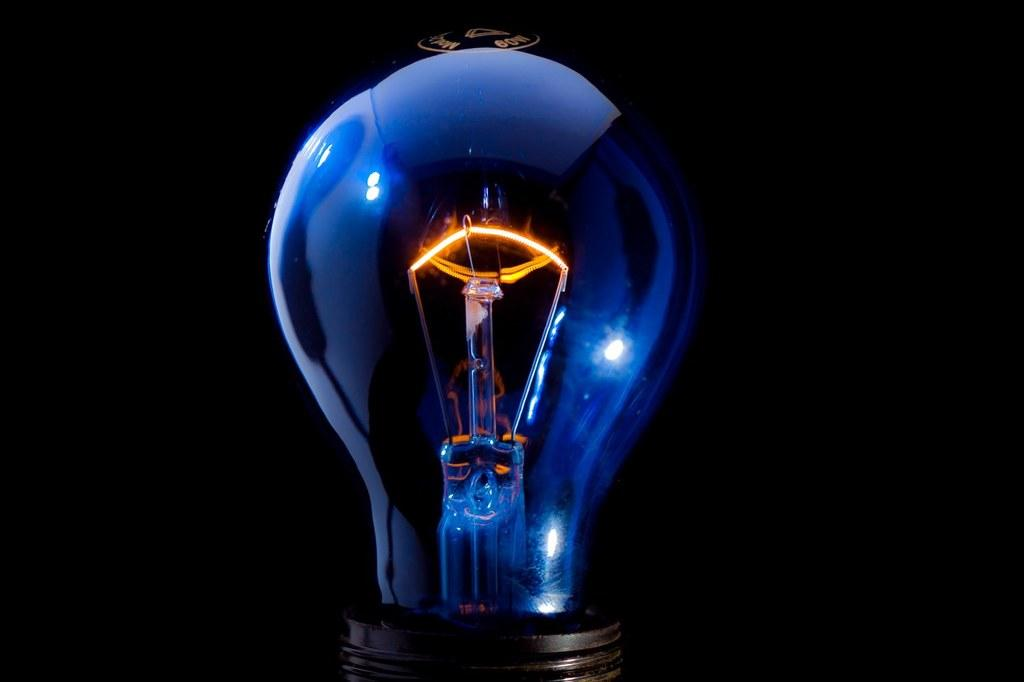What is the main object in the center of the image? There is a bulb in the center of the image. What type of trick can be performed with the bulb in the image? There is no trick being performed with the bulb in the image; it is simply a stationary object in the center of the image. 